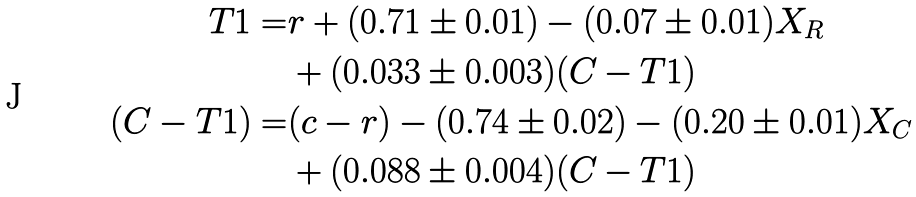Convert formula to latex. <formula><loc_0><loc_0><loc_500><loc_500>T 1 = & r + ( 0 . 7 1 \pm 0 . 0 1 ) - ( 0 . 0 7 \pm 0 . 0 1 ) X _ { R } \\ & + ( 0 . 0 3 3 \pm 0 . 0 0 3 ) ( C - T 1 ) \\ ( C - T 1 ) = & ( c - r ) - ( 0 . 7 4 \pm 0 . 0 2 ) - ( 0 . 2 0 \pm 0 . 0 1 ) X _ { C } \\ & + ( 0 . 0 8 8 \pm 0 . 0 0 4 ) ( C - T 1 )</formula> 